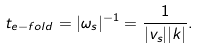Convert formula to latex. <formula><loc_0><loc_0><loc_500><loc_500>t _ { e - f o l d } = | \omega _ { s } | ^ { - 1 } = \frac { 1 } { | v _ { s } | | k | } .</formula> 